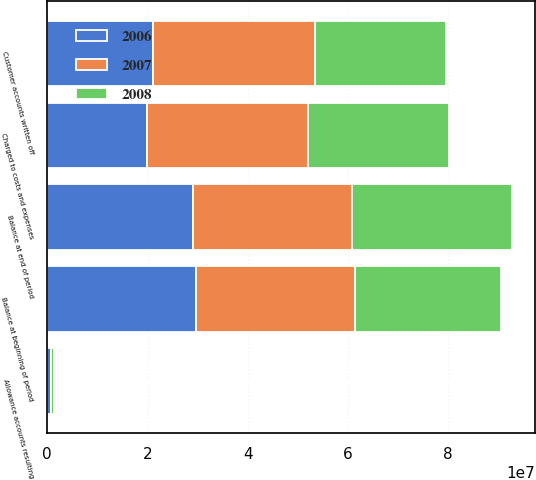Convert chart to OTSL. <chart><loc_0><loc_0><loc_500><loc_500><stacked_bar_chart><ecel><fcel>Balance at beginning of period<fcel>Charged to costs and expenses<fcel>Allowance accounts resulting<fcel>Customer accounts written off<fcel>Balance at end of period<nl><fcel>2007<fcel>3.1841e+07<fcel>3.2185e+07<fcel>71000<fcel>3.2367e+07<fcel>3.173e+07<nl><fcel>2008<fcel>2.91e+07<fcel>2.8156e+07<fcel>595000<fcel>2.601e+07<fcel>3.1841e+07<nl><fcel>2006<fcel>2.9604e+07<fcel>1.9895e+07<fcel>729000<fcel>2.1128e+07<fcel>2.91e+07<nl></chart> 